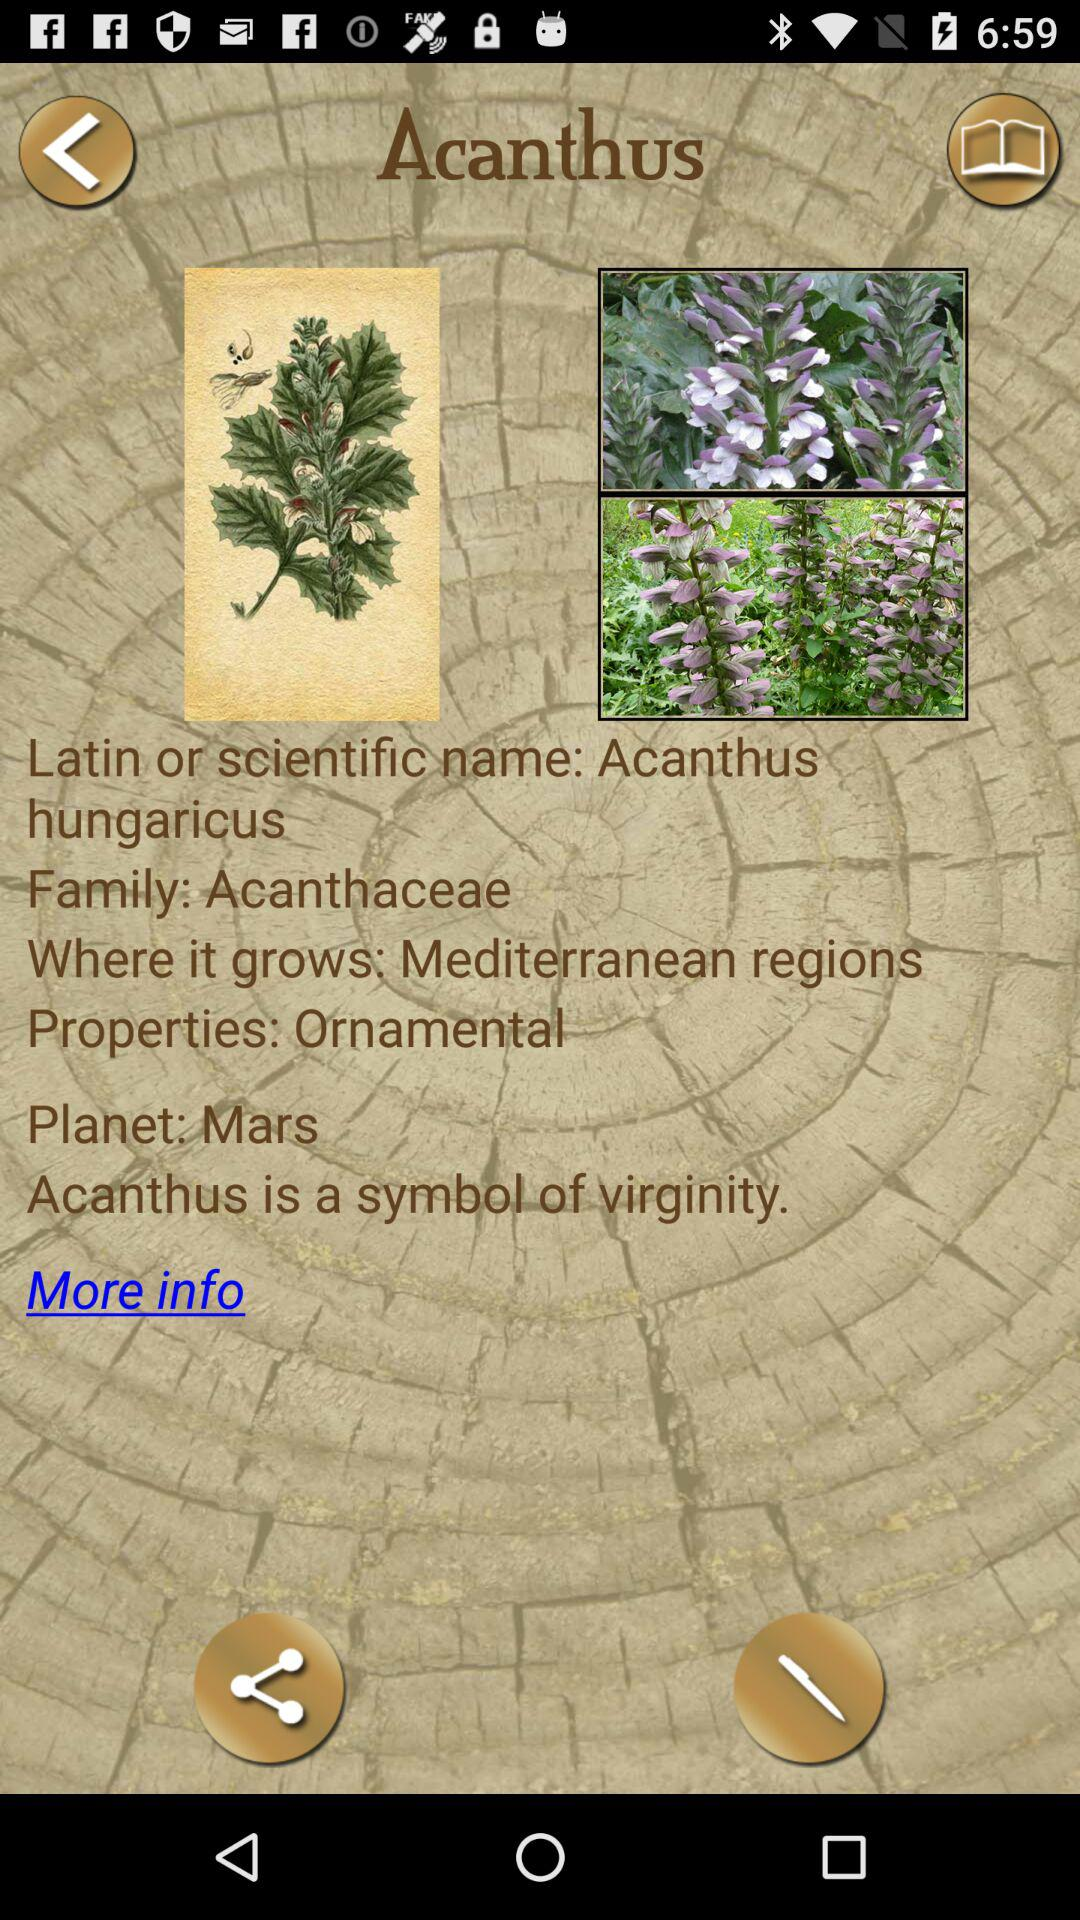To what family does the Acanthus belong? Acanthus belongs to the "Acanthaceae" family. 